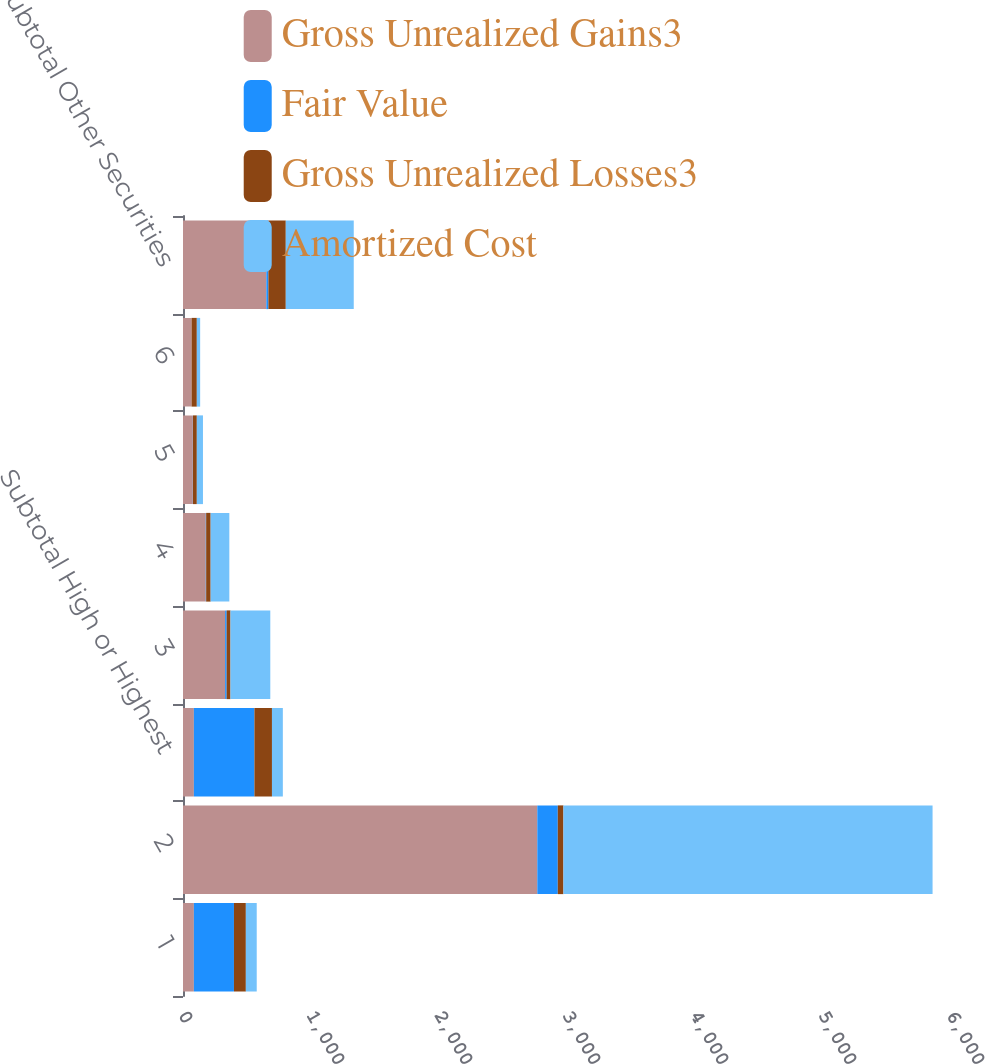Convert chart to OTSL. <chart><loc_0><loc_0><loc_500><loc_500><stacked_bar_chart><ecel><fcel>1<fcel>2<fcel>Subtotal High or Highest<fcel>3<fcel>4<fcel>5<fcel>6<fcel>Subtotal Other Securities<nl><fcel>Gross Unrealized Gains3<fcel>85<fcel>2768<fcel>85<fcel>329<fcel>178<fcel>77<fcel>67<fcel>651<nl><fcel>Fair Value<fcel>313<fcel>160<fcel>473<fcel>12<fcel>3<fcel>1<fcel>0<fcel>16<nl><fcel>Gross Unrealized Losses3<fcel>93<fcel>44<fcel>137<fcel>30<fcel>35<fcel>30<fcel>41<fcel>136<nl><fcel>Amortized Cost<fcel>85<fcel>2884<fcel>85<fcel>311<fcel>146<fcel>48<fcel>26<fcel>531<nl></chart> 